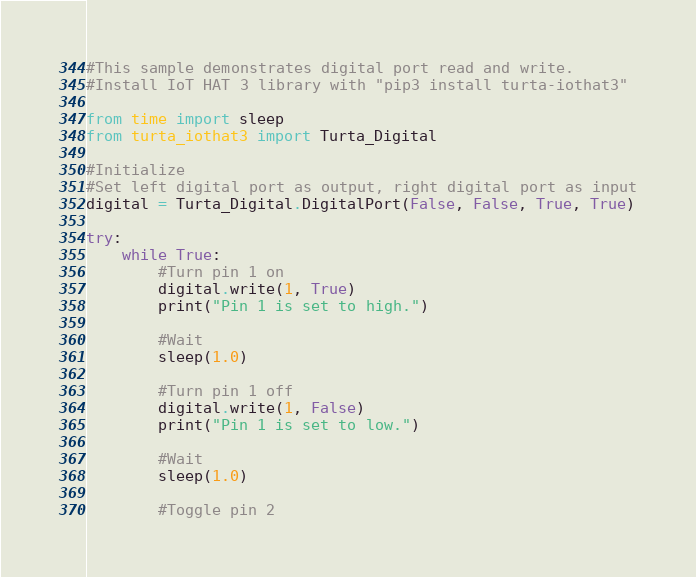<code> <loc_0><loc_0><loc_500><loc_500><_Python_>#This sample demonstrates digital port read and write.
#Install IoT HAT 3 library with "pip3 install turta-iothat3"

from time import sleep
from turta_iothat3 import Turta_Digital

#Initialize
#Set left digital port as output, right digital port as input
digital = Turta_Digital.DigitalPort(False, False, True, True)

try:
    while True:
        #Turn pin 1 on
        digital.write(1, True)
        print("Pin 1 is set to high.")

        #Wait
        sleep(1.0)

        #Turn pin 1 off
        digital.write(1, False)
        print("Pin 1 is set to low.")

        #Wait
        sleep(1.0)

        #Toggle pin 2</code> 